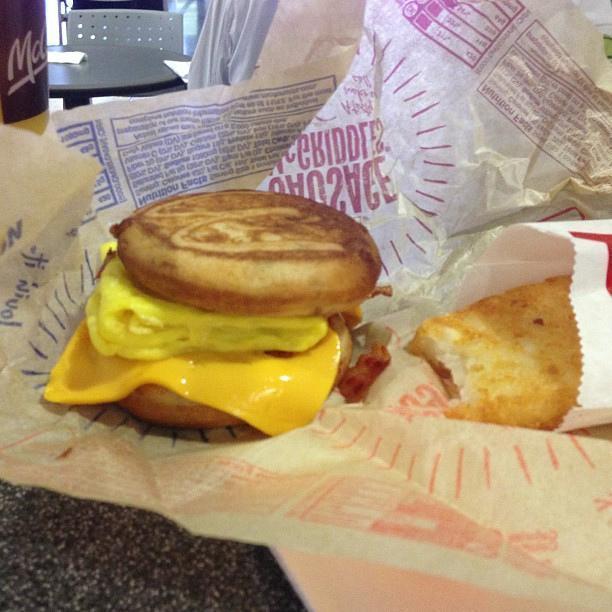How many sandwiches can you see?
Give a very brief answer. 2. How many dining tables are there?
Give a very brief answer. 2. 